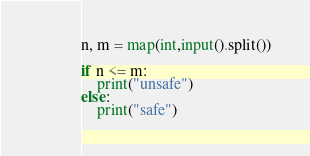Convert code to text. <code><loc_0><loc_0><loc_500><loc_500><_Python_>
n, m = map(int,input().split())

if n <= m:
    print("unsafe")
else:
    print("safe")</code> 